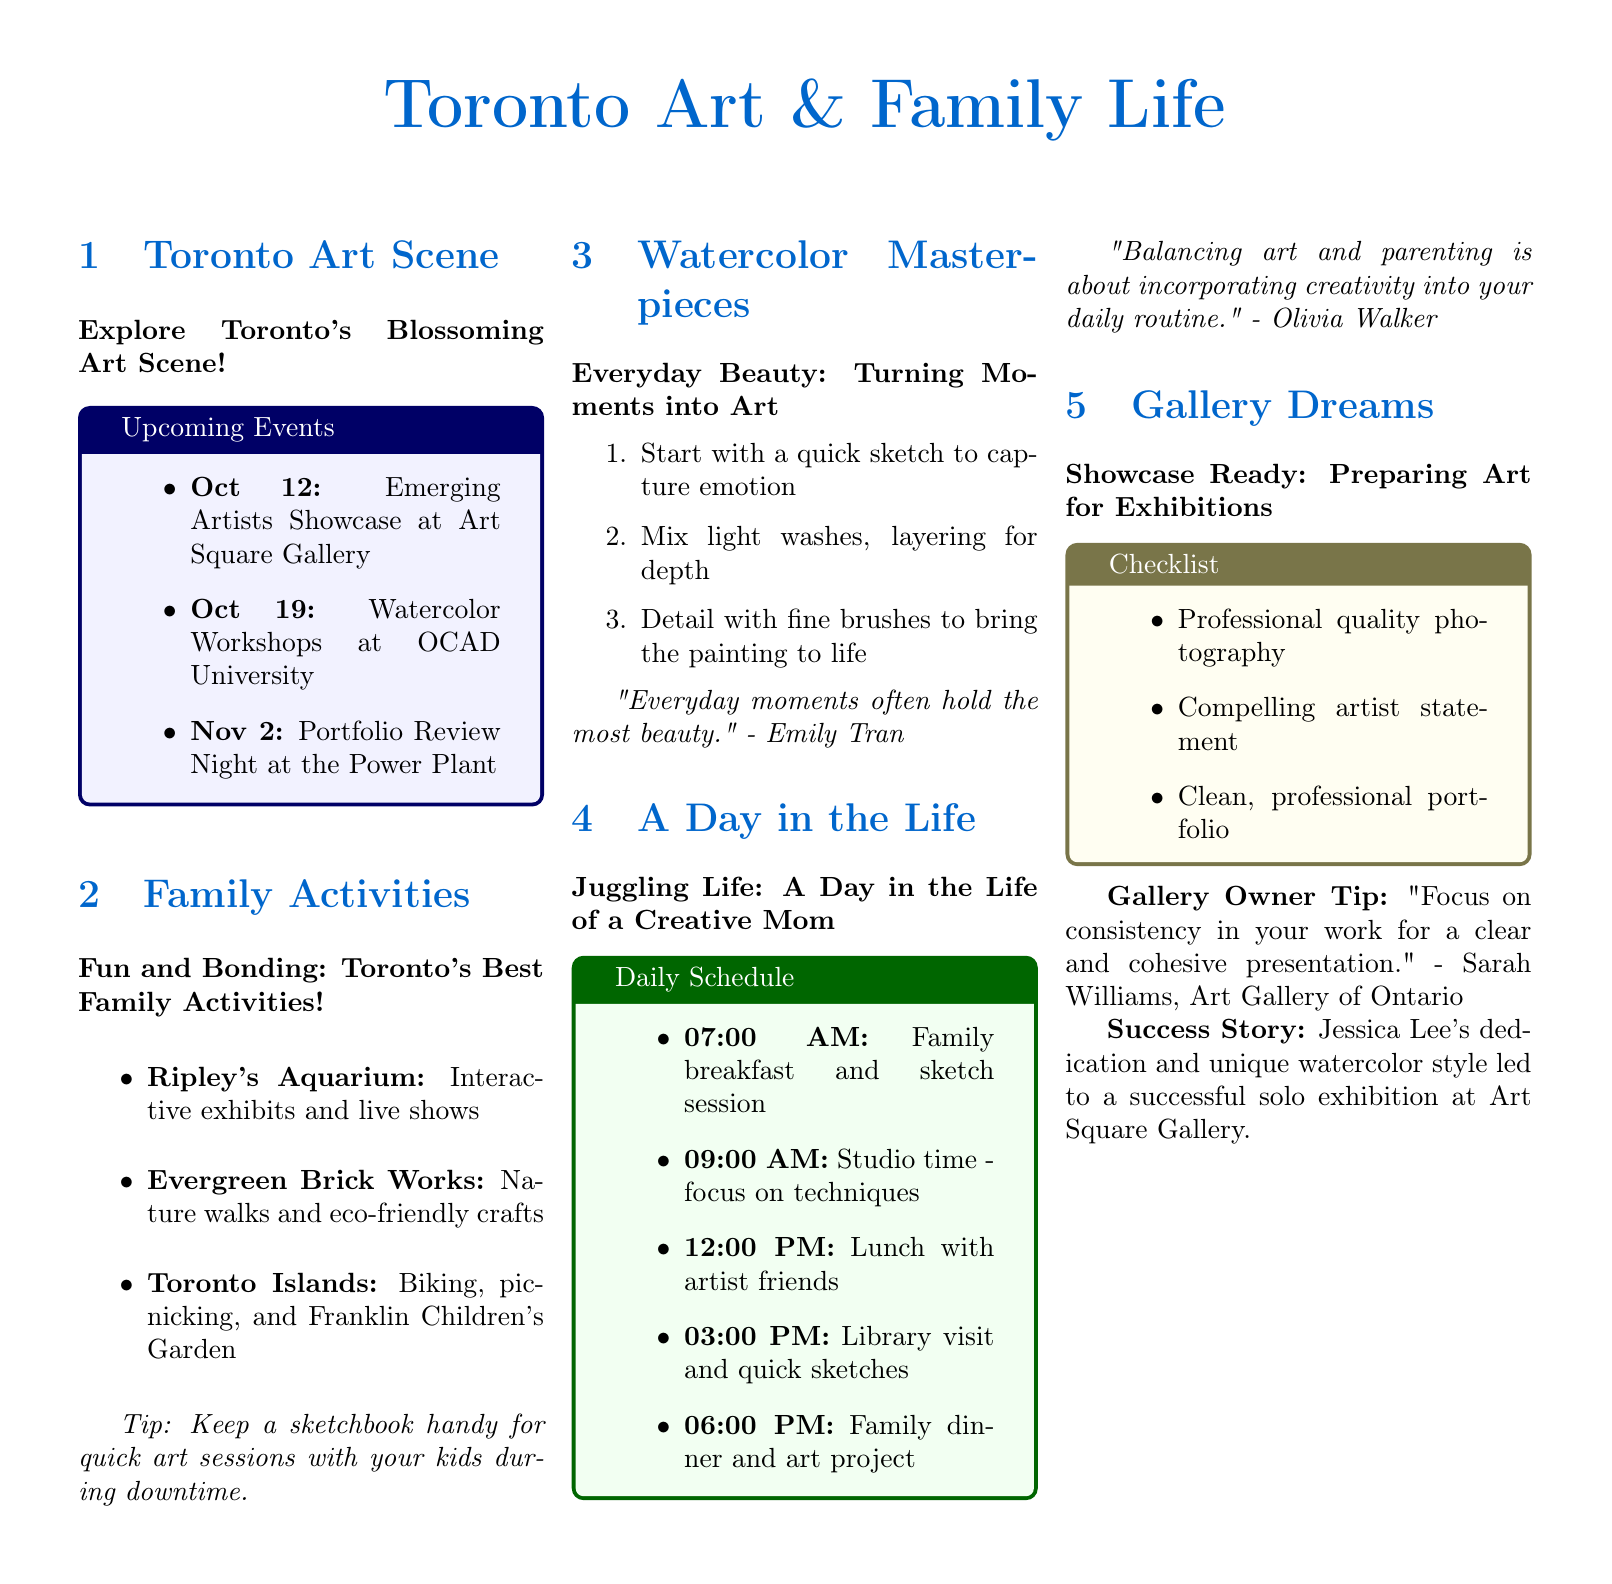What is the title of the first section? The title of the first section is centered and bolded, referring to the Toronto art events.
Answer: Toronto Art Scene How many events are listed in the Upcoming Events box? The Upcoming Events box contains a list of events related to the Toronto art scene.
Answer: 3 What is one activity you can do at the Toronto Islands? The document lists specific activities available at the Toronto Islands, focusing on family-friendly options.
Answer: Biking What quotation is attributed to Emily Tran? The section includes a motivational quote from a local artist that reflects on art and beauty.
Answer: "Everyday moments often hold the most beauty." At what time does the family breakfast occur according to the Daily Schedule? The Daily Schedule provides a timeline for a typical day balancing art and family.
Answer: 07:00 AM Which art-related tip is given by Sarah Williams? This piece includes valuable advice from a gallery owner about showcasing art effectively.
Answer: "Focus on consistency in your work for a clear and cohesive presentation." What type of painting technique is suggested in the Watercolor Masterpieces section? This section provides guidance on artistic techniques to enhance painting.
Answer: Light washes Who is the artist mentioned in the success story from the Gallery Dreams section? The success story highlights the achievements of a specific artist in the local art community.
Answer: Jessica Lee 